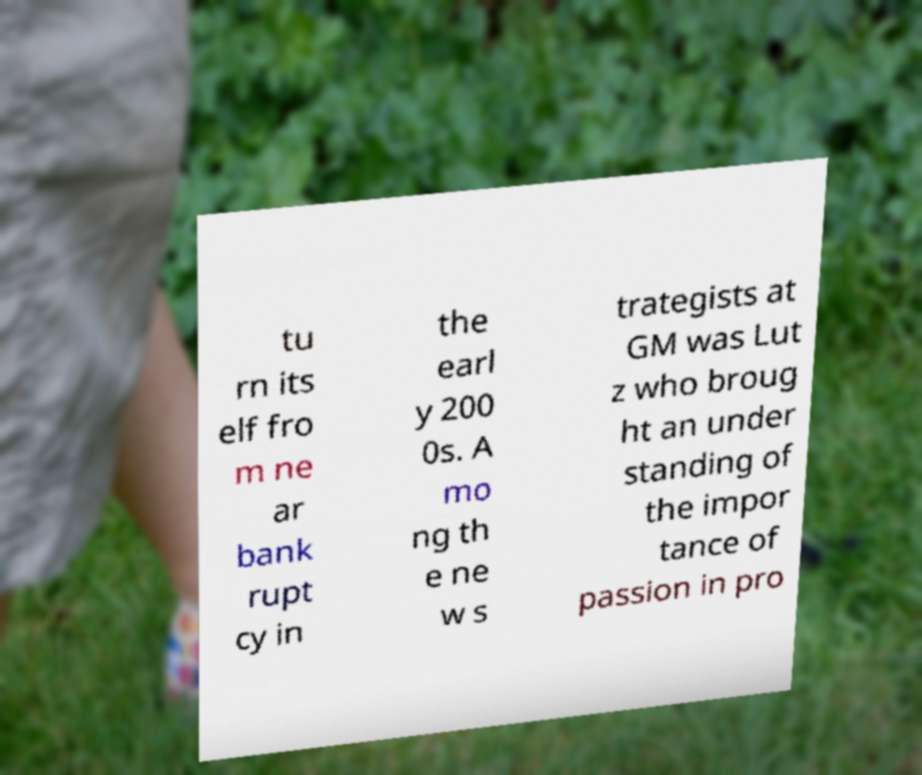Please identify and transcribe the text found in this image. tu rn its elf fro m ne ar bank rupt cy in the earl y 200 0s. A mo ng th e ne w s trategists at GM was Lut z who broug ht an under standing of the impor tance of passion in pro 